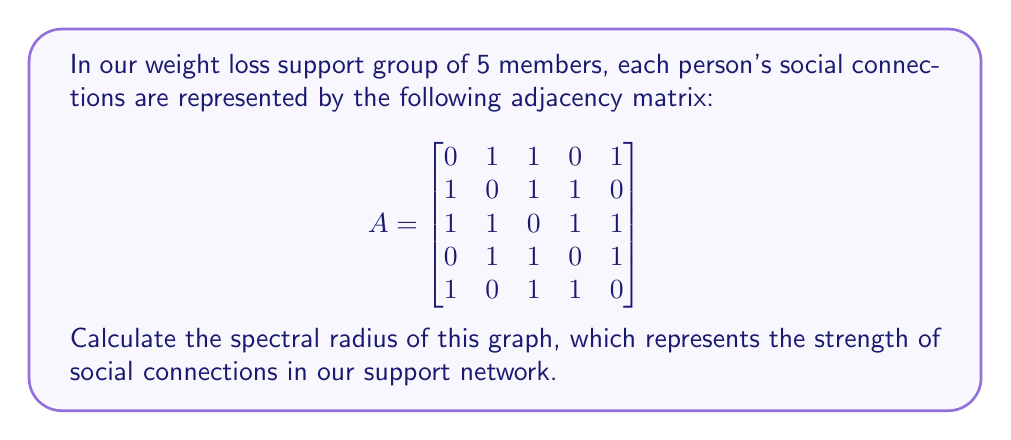Teach me how to tackle this problem. To find the spectral radius of the graph, we need to follow these steps:

1) The spectral radius is the largest absolute eigenvalue of the adjacency matrix A.

2) To find the eigenvalues, we need to solve the characteristic equation:
   $$det(A - \lambda I) = 0$$
   where $I$ is the 5x5 identity matrix and $\lambda$ represents the eigenvalues.

3) Expanding this determinant gives us the characteristic polynomial:
   $$\lambda^5 - 10\lambda^3 - 8\lambda^2 + 5\lambda + 4 = 0$$

4) This polynomial is difficult to solve analytically, so we'll use numerical methods to approximate the roots.

5) Using a numerical solver, we find that the roots (eigenvalues) are approximately:
   $\lambda_1 \approx 2.7321$
   $\lambda_2 \approx -1.7321$
   $\lambda_3 \approx 1.0000$
   $\lambda_4 \approx -1.0000$
   $\lambda_5 \approx 0.0000$

6) The spectral radius is the largest absolute value among these eigenvalues.

7) Therefore, the spectral radius is approximately 2.7321.

This value represents the overall connectivity and influence potential in our weight loss support network. A higher spectral radius indicates stronger and more evenly distributed connections, which can lead to better support and motivation for our intermittent fasting program.
Answer: $2.7321$ 